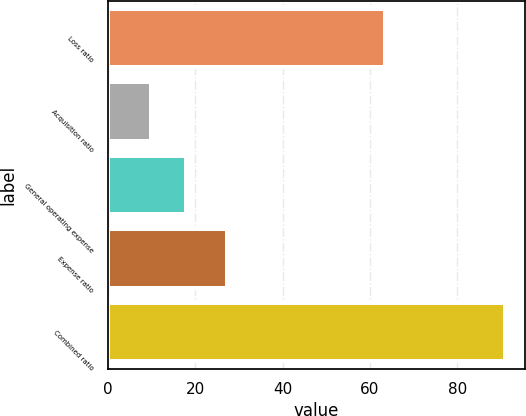<chart> <loc_0><loc_0><loc_500><loc_500><bar_chart><fcel>Loss ratio<fcel>Acquisition ratio<fcel>General operating expense<fcel>Expense ratio<fcel>Combined ratio<nl><fcel>63.5<fcel>9.9<fcel>18<fcel>27.4<fcel>90.9<nl></chart> 